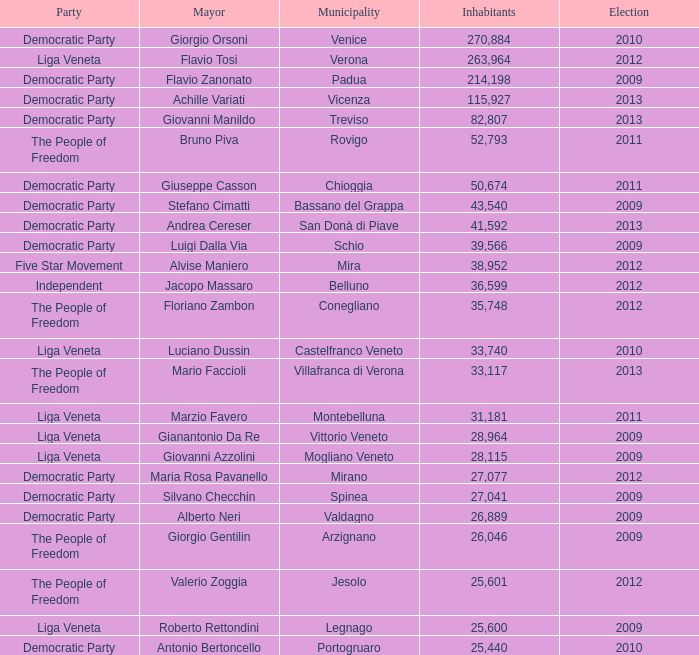Give me the full table as a dictionary. {'header': ['Party', 'Mayor', 'Municipality', 'Inhabitants', 'Election'], 'rows': [['Democratic Party', 'Giorgio Orsoni', 'Venice', '270,884', '2010'], ['Liga Veneta', 'Flavio Tosi', 'Verona', '263,964', '2012'], ['Democratic Party', 'Flavio Zanonato', 'Padua', '214,198', '2009'], ['Democratic Party', 'Achille Variati', 'Vicenza', '115,927', '2013'], ['Democratic Party', 'Giovanni Manildo', 'Treviso', '82,807', '2013'], ['The People of Freedom', 'Bruno Piva', 'Rovigo', '52,793', '2011'], ['Democratic Party', 'Giuseppe Casson', 'Chioggia', '50,674', '2011'], ['Democratic Party', 'Stefano Cimatti', 'Bassano del Grappa', '43,540', '2009'], ['Democratic Party', 'Andrea Cereser', 'San Donà di Piave', '41,592', '2013'], ['Democratic Party', 'Luigi Dalla Via', 'Schio', '39,566', '2009'], ['Five Star Movement', 'Alvise Maniero', 'Mira', '38,952', '2012'], ['Independent', 'Jacopo Massaro', 'Belluno', '36,599', '2012'], ['The People of Freedom', 'Floriano Zambon', 'Conegliano', '35,748', '2012'], ['Liga Veneta', 'Luciano Dussin', 'Castelfranco Veneto', '33,740', '2010'], ['The People of Freedom', 'Mario Faccioli', 'Villafranca di Verona', '33,117', '2013'], ['Liga Veneta', 'Marzio Favero', 'Montebelluna', '31,181', '2011'], ['Liga Veneta', 'Gianantonio Da Re', 'Vittorio Veneto', '28,964', '2009'], ['Liga Veneta', 'Giovanni Azzolini', 'Mogliano Veneto', '28,115', '2009'], ['Democratic Party', 'Maria Rosa Pavanello', 'Mirano', '27,077', '2012'], ['Democratic Party', 'Silvano Checchin', 'Spinea', '27,041', '2009'], ['Democratic Party', 'Alberto Neri', 'Valdagno', '26,889', '2009'], ['The People of Freedom', 'Giorgio Gentilin', 'Arzignano', '26,046', '2009'], ['The People of Freedom', 'Valerio Zoggia', 'Jesolo', '25,601', '2012'], ['Liga Veneta', 'Roberto Rettondini', 'Legnago', '25,600', '2009'], ['Democratic Party', 'Antonio Bertoncello', 'Portogruaro', '25,440', '2010']]} How many elections had more than 36,599 inhabitants when Mayor was giovanni manildo? 1.0. 